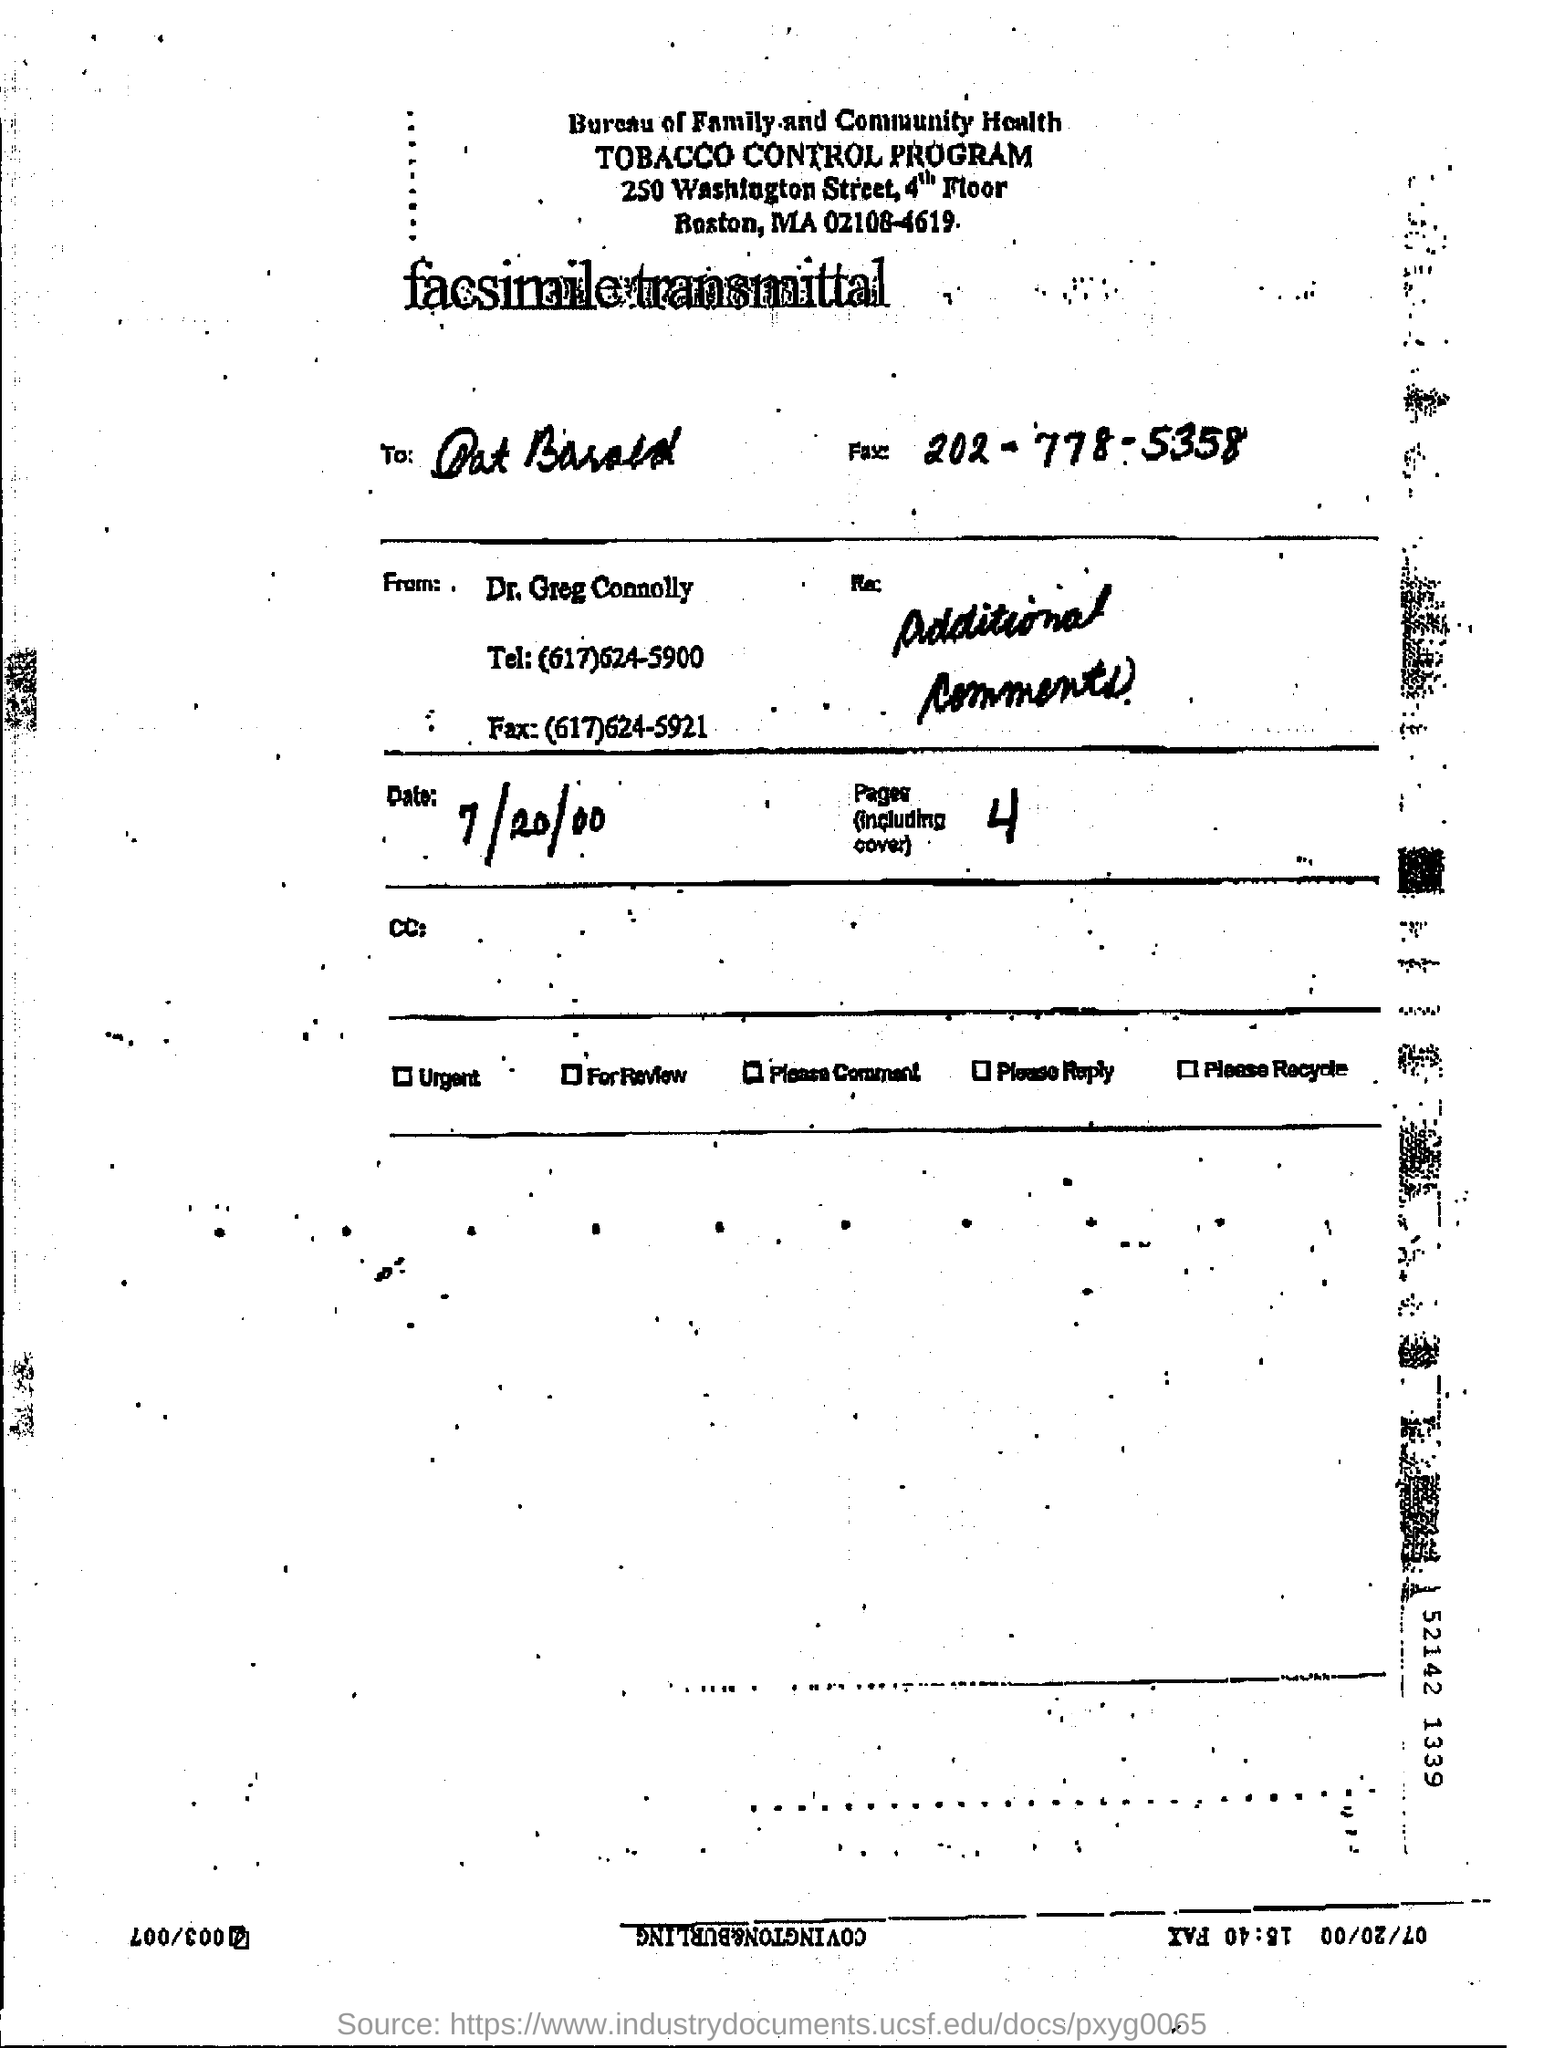how many pages are there (including cover) ?
 4 